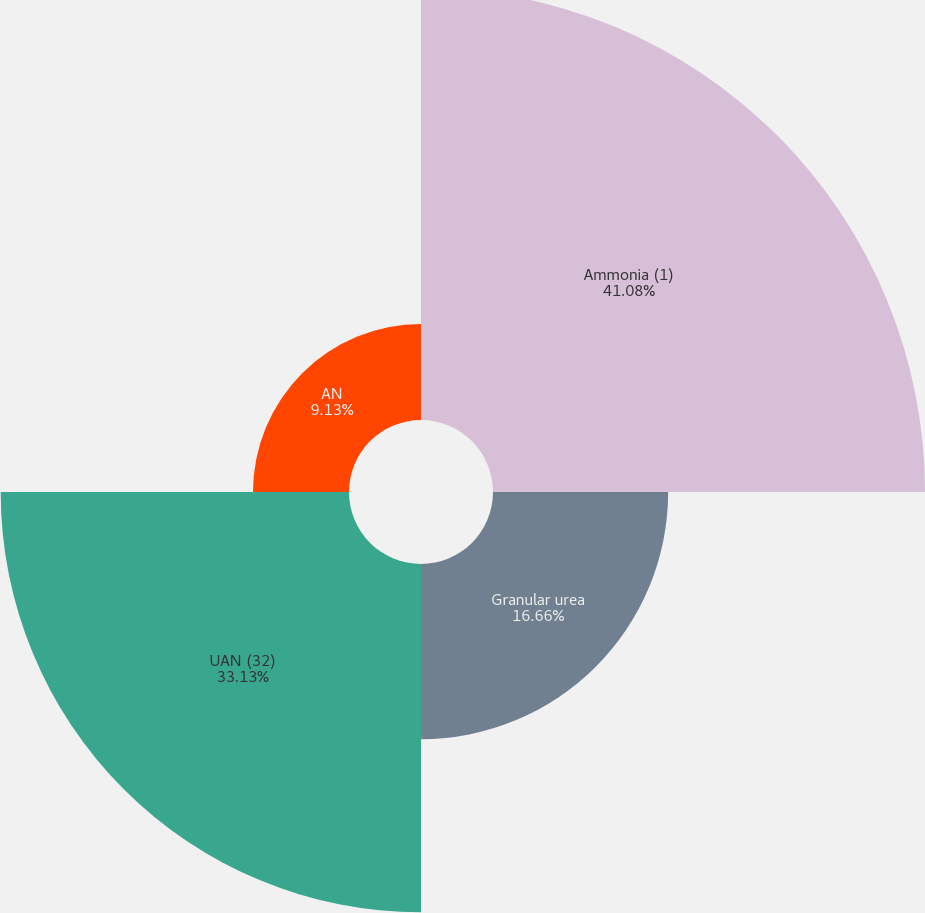Convert chart to OTSL. <chart><loc_0><loc_0><loc_500><loc_500><pie_chart><fcel>Ammonia (1)<fcel>Granular urea<fcel>UAN (32)<fcel>AN<nl><fcel>41.09%<fcel>16.66%<fcel>33.13%<fcel>9.13%<nl></chart> 